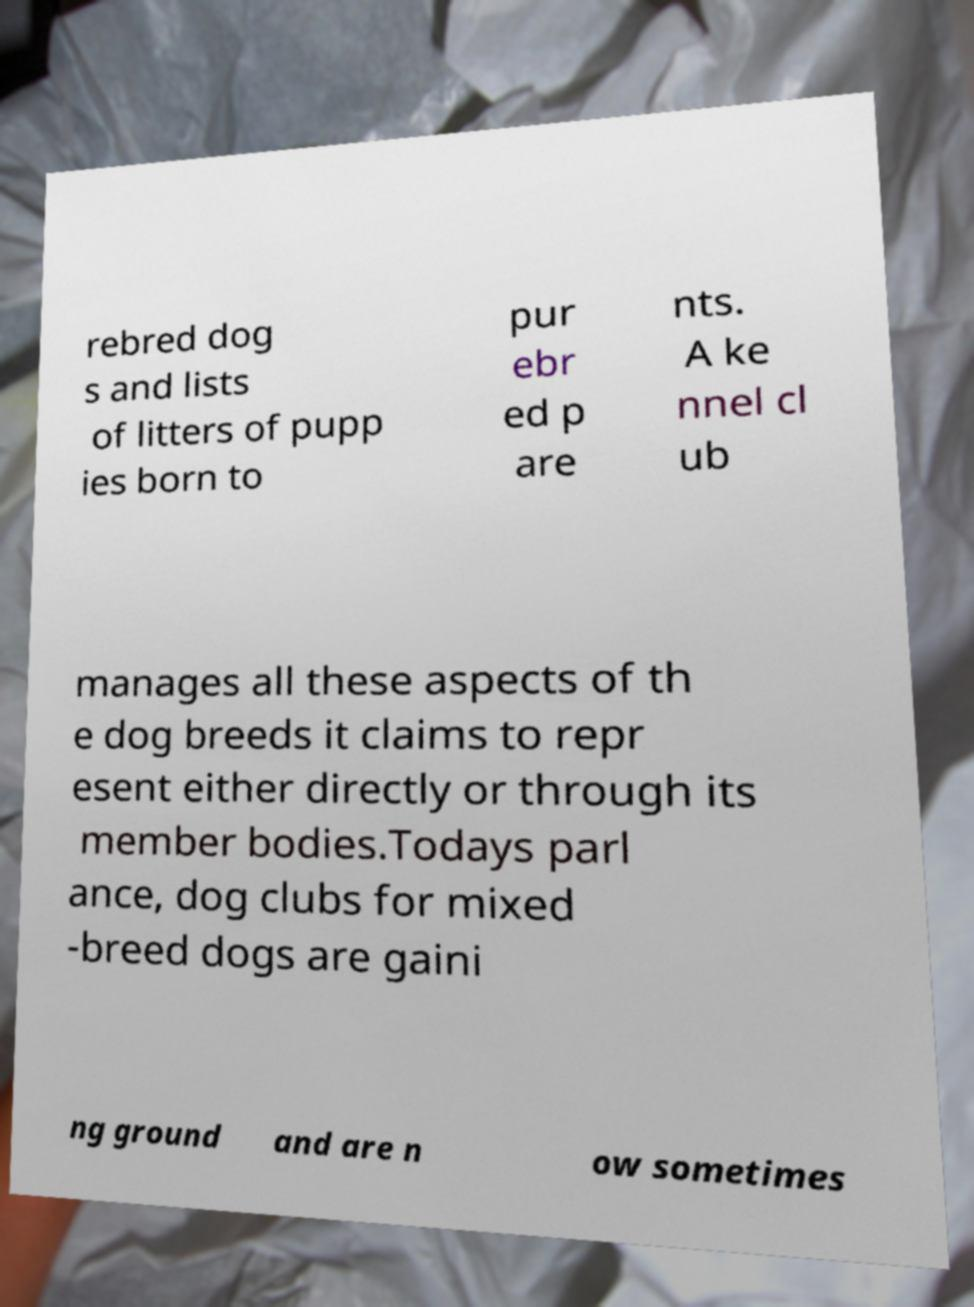There's text embedded in this image that I need extracted. Can you transcribe it verbatim? rebred dog s and lists of litters of pupp ies born to pur ebr ed p are nts. A ke nnel cl ub manages all these aspects of th e dog breeds it claims to repr esent either directly or through its member bodies.Todays parl ance, dog clubs for mixed -breed dogs are gaini ng ground and are n ow sometimes 